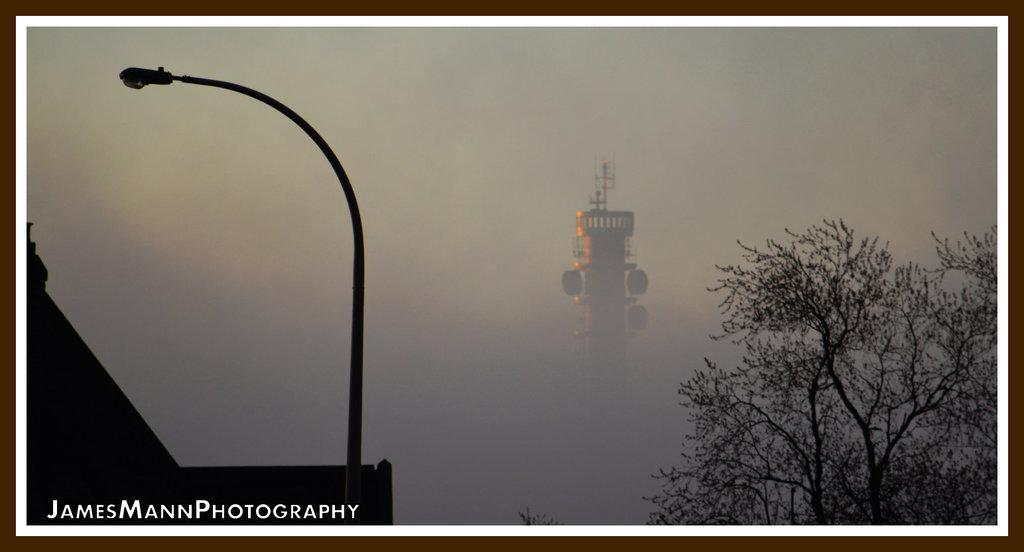What is the main structure in the center of the image? There is a tower in the center of the image. What type of vegetation is on the right side of the image? There is a tree on the right side of the image. What objects are on the left side of the image? There is a pole and a light on the left side of the image. What can be seen in the background of the image? The sky is visible in the background of the image. What type of chicken can be seen in the image? There is no chicken present in the image. What does the tower taste like in the image? The tower is a structure and cannot be tasted. 